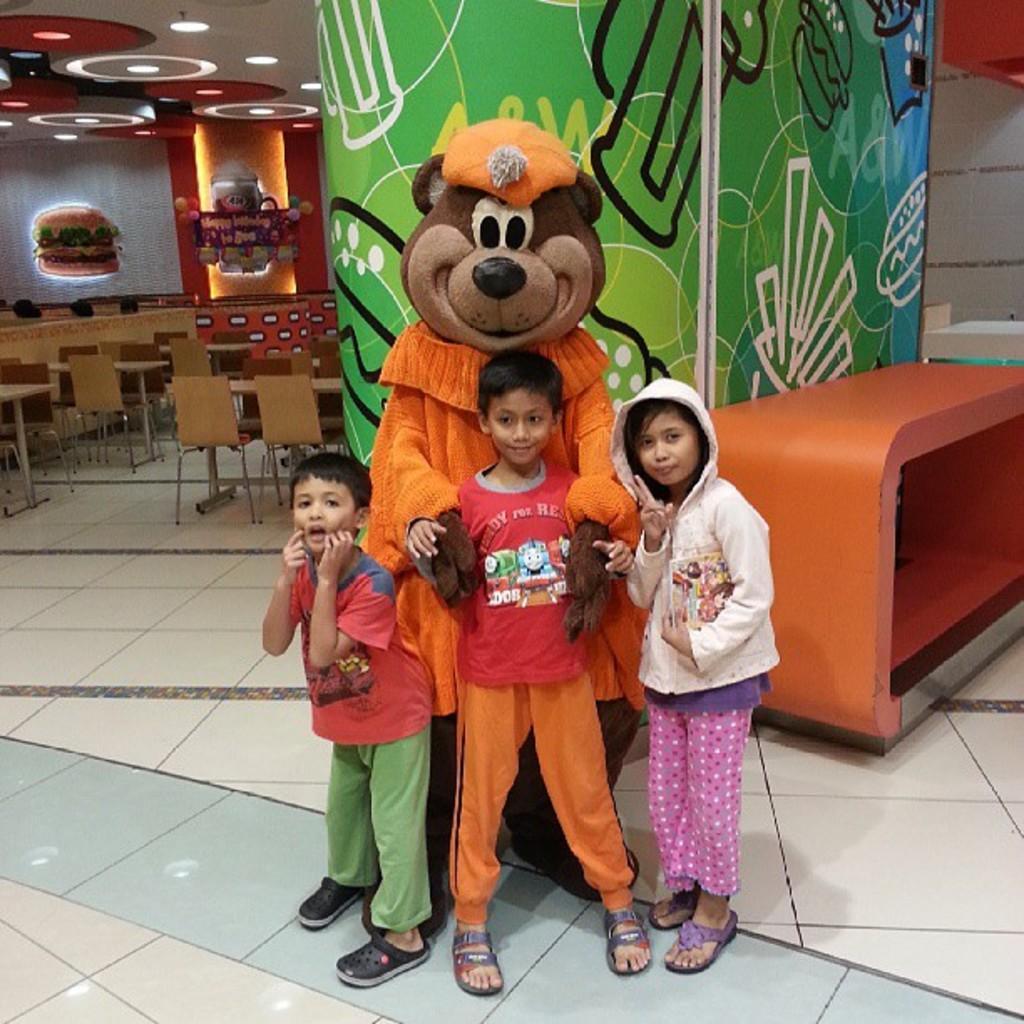Describe this image in one or two sentences. In this image I can see few children and a teddy bear. In the background I can see number of chairs, few tables and number of lights on ceiling. 